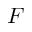<formula> <loc_0><loc_0><loc_500><loc_500>F</formula> 